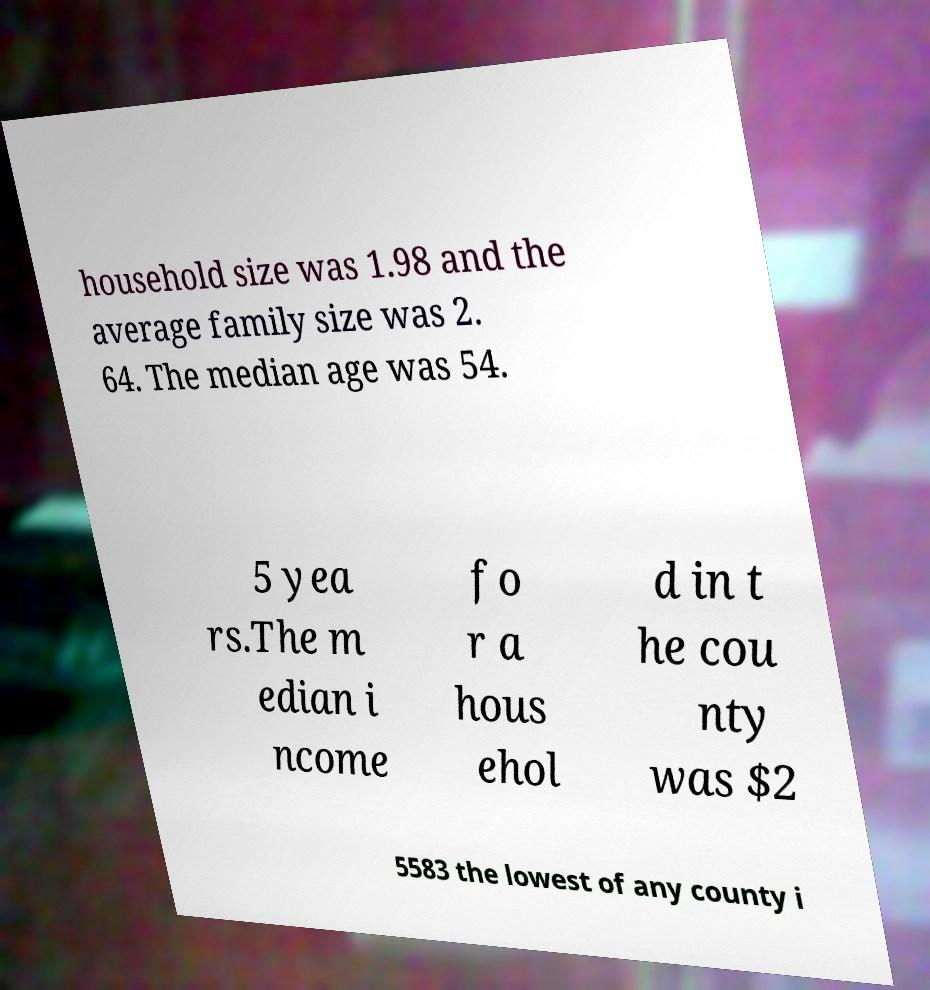I need the written content from this picture converted into text. Can you do that? household size was 1.98 and the average family size was 2. 64. The median age was 54. 5 yea rs.The m edian i ncome fo r a hous ehol d in t he cou nty was $2 5583 the lowest of any county i 